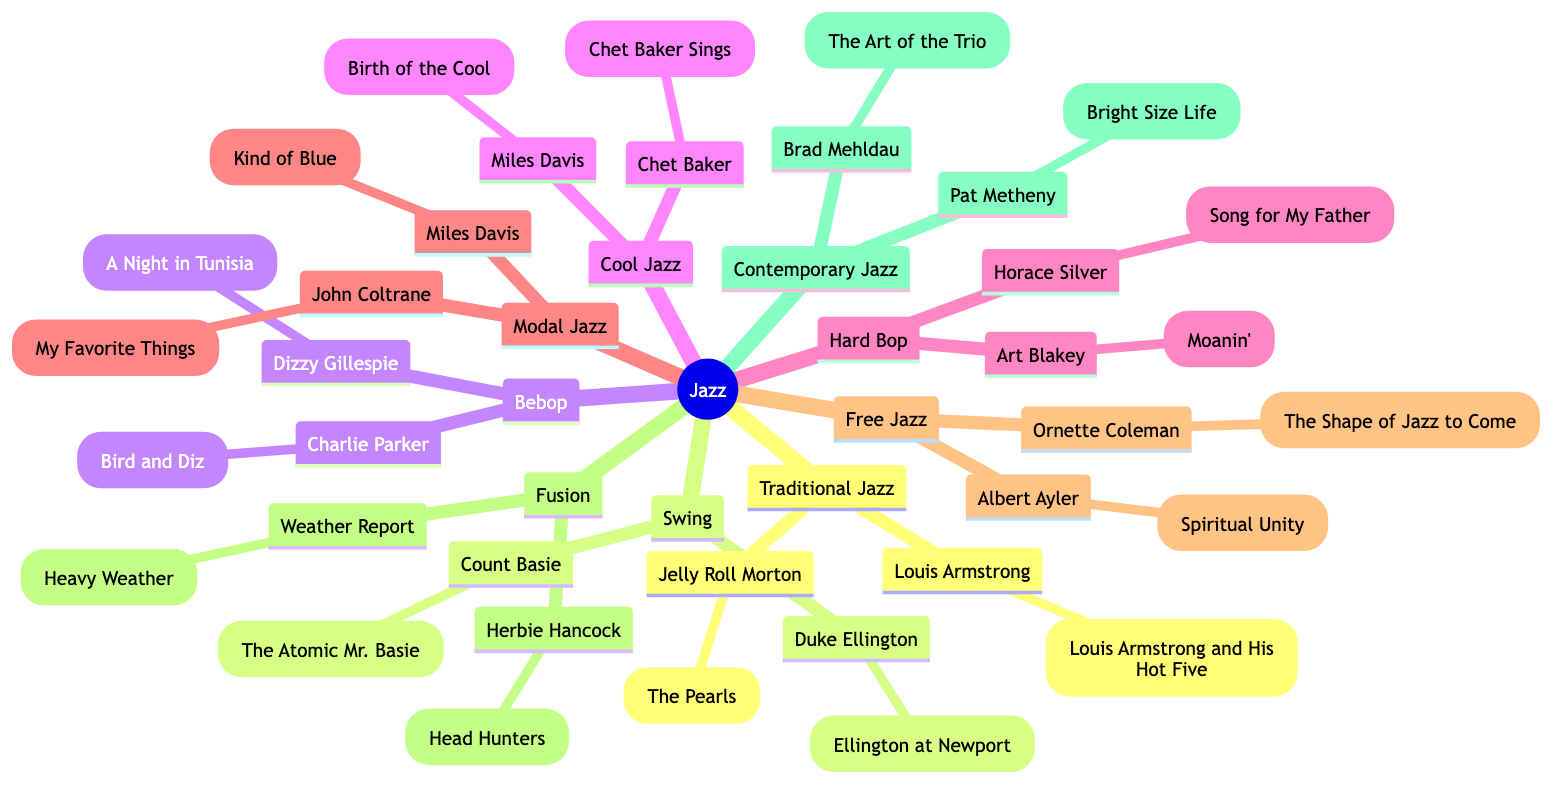What are the key artists in Traditional Jazz? The diagram indicates that the key artists under Traditional Jazz are listed directly below its node. They are Louis Armstrong and Jelly Roll Morton.
Answer: Louis Armstrong, Jelly Roll Morton How many subgenres are there under Jazz? By counting the distinct categories listed under the Jazz node, there is a total of nine subgenres: Traditional Jazz, Swing, Bebop, Cool Jazz, Hard Bop, Modal Jazz, Free Jazz, Fusion, and Contemporary Jazz.
Answer: 9 Which subgenre features Miles Davis as a key artist? Miles Davis is listed as a key artist under both Cool Jazz and Modal Jazz. To answer the question, you would look at each of the subgenre nodes.
Answer: Cool Jazz, Modal Jazz What album is specifically associated with Duke Ellington? To find the answer, you would examine the Swing subgenre node which indicates that Duke Ellington is associated with the album "Ellington at Newport."
Answer: Ellington at Newport Which subgenre has two key artists listed under it? By examining the subgenres, you would find that several subgenres have two key artists. However, each of the listed subgenres contains exactly two key artists. An example would be Hard Bop, which features Art Blakey and Horace Silver.
Answer: All subgenres 